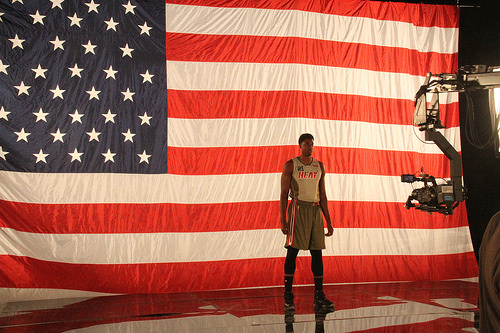<image>
Is there a man in front of the some cameras? Yes. The man is positioned in front of the some cameras, appearing closer to the camera viewpoint. 